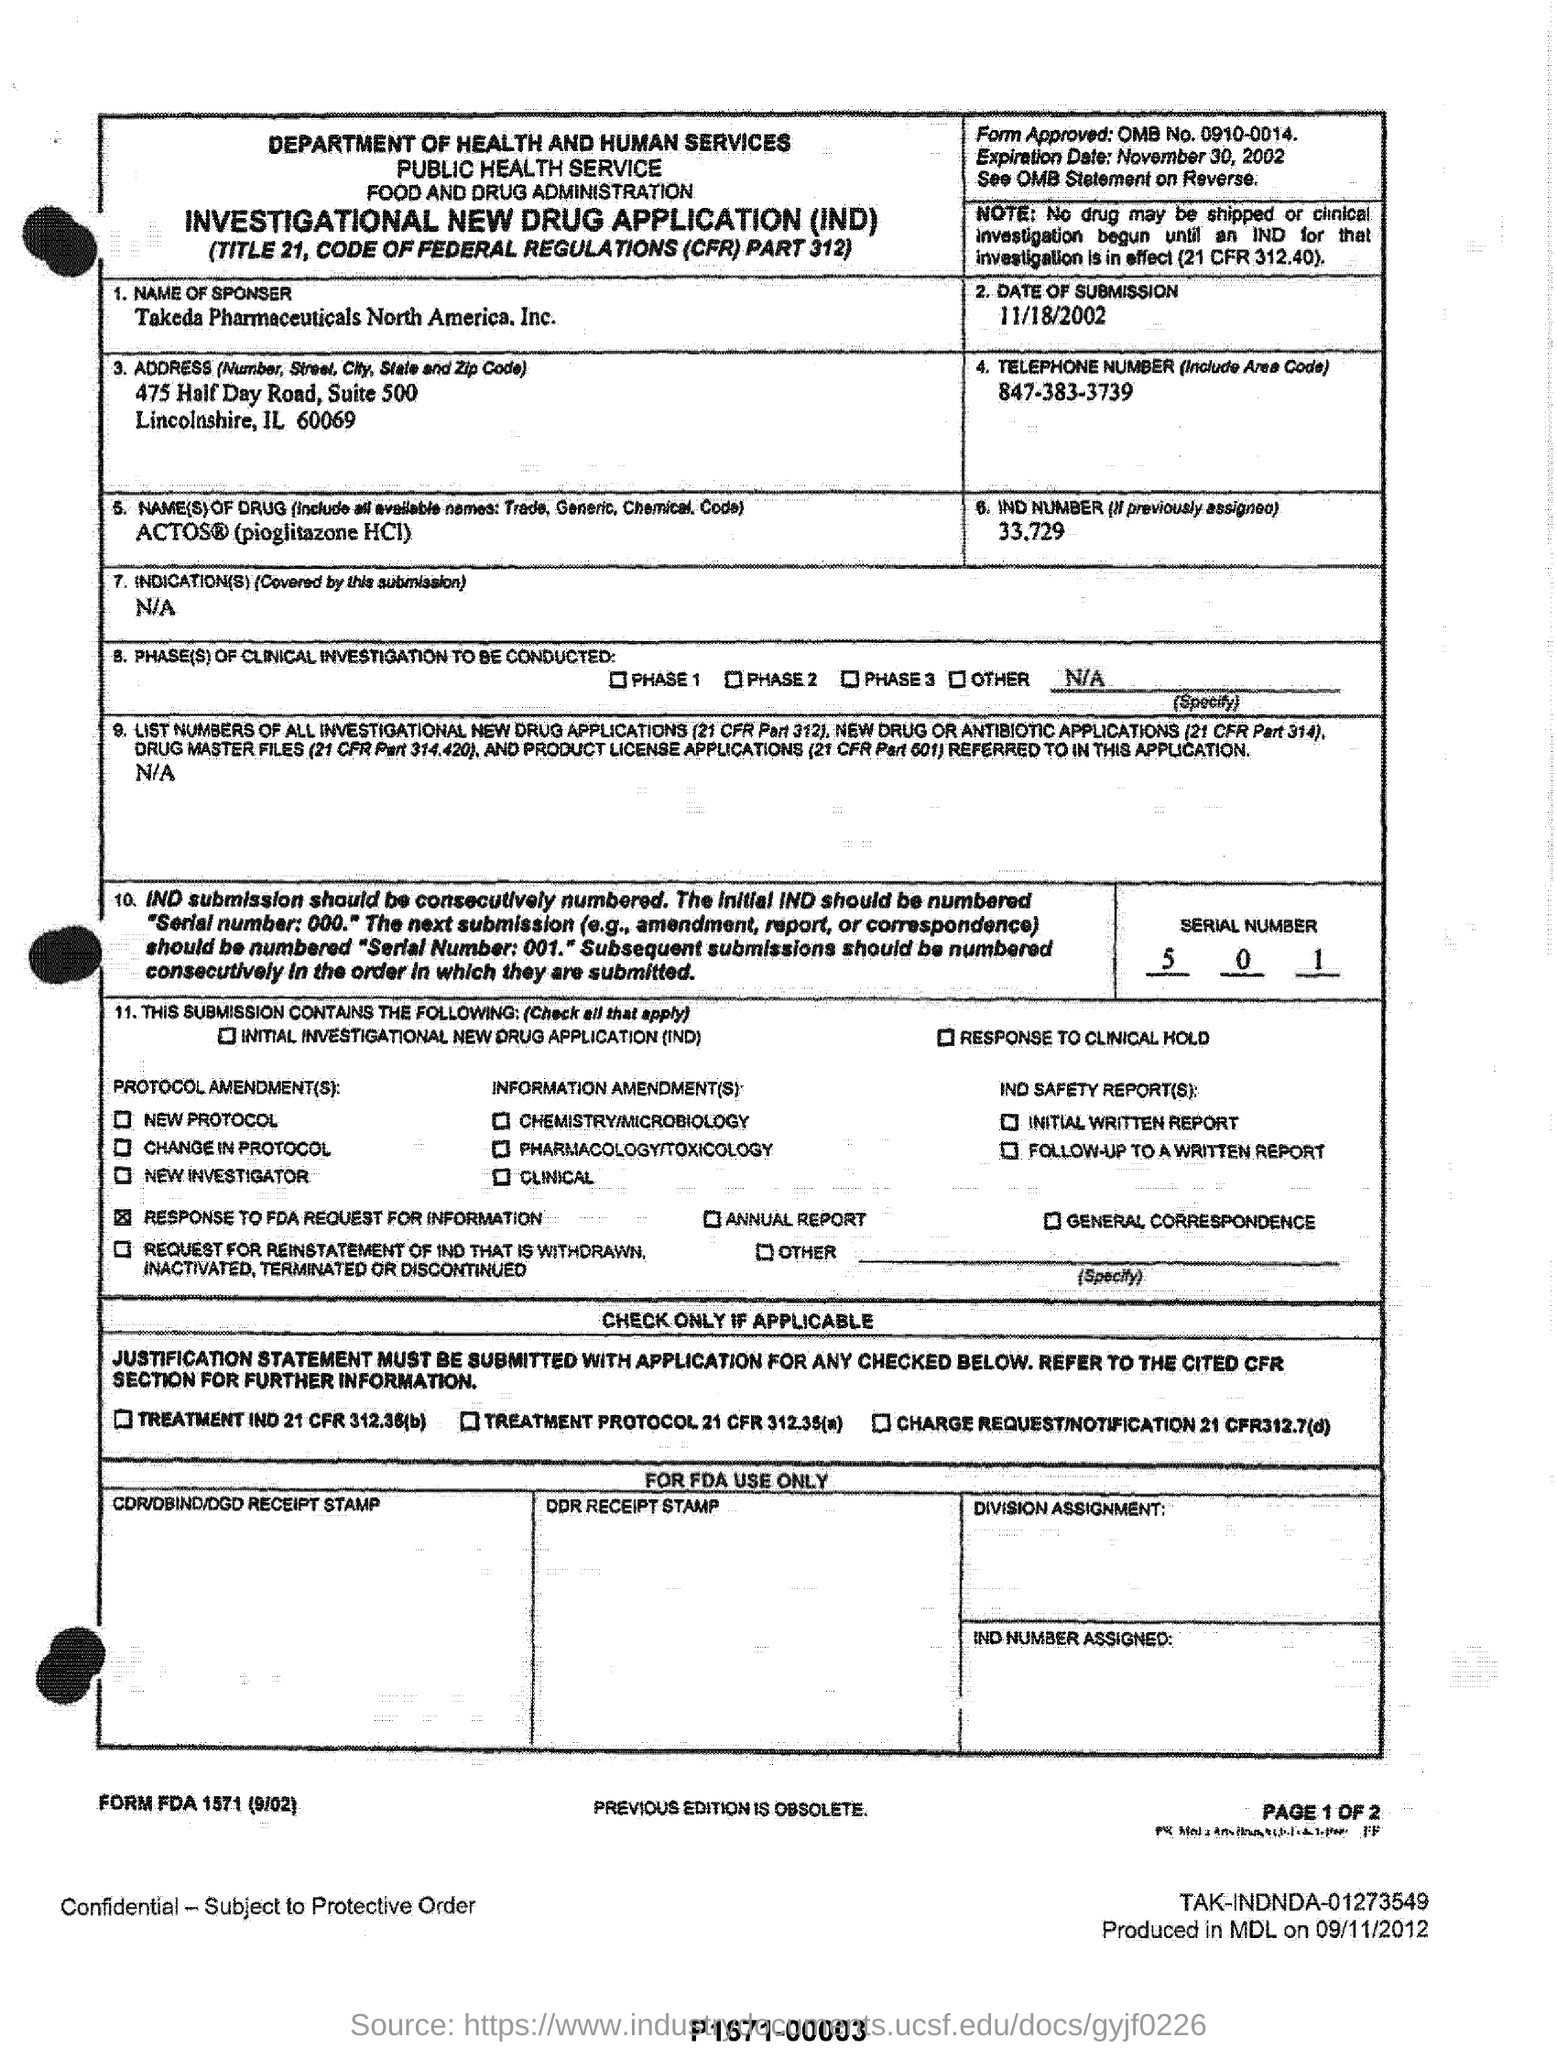List a handful of essential elements in this visual. Takeda Pharmaceuticals North America, Inc. is the sponsor of this event. On what date was the submission made? The telephone number, including the area code, is 847-383-3739. The department of health and human services belongs to which department? The expiration date is November 30, 2002. 